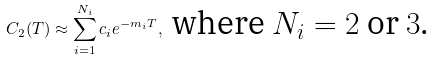Convert formula to latex. <formula><loc_0><loc_0><loc_500><loc_500>C _ { 2 } ( T ) \approx \sum _ { i = 1 } ^ { N _ { i } } c _ { i } e ^ { - m _ { i } T } , \text { where $N_{i}=2$ or $3$.}</formula> 